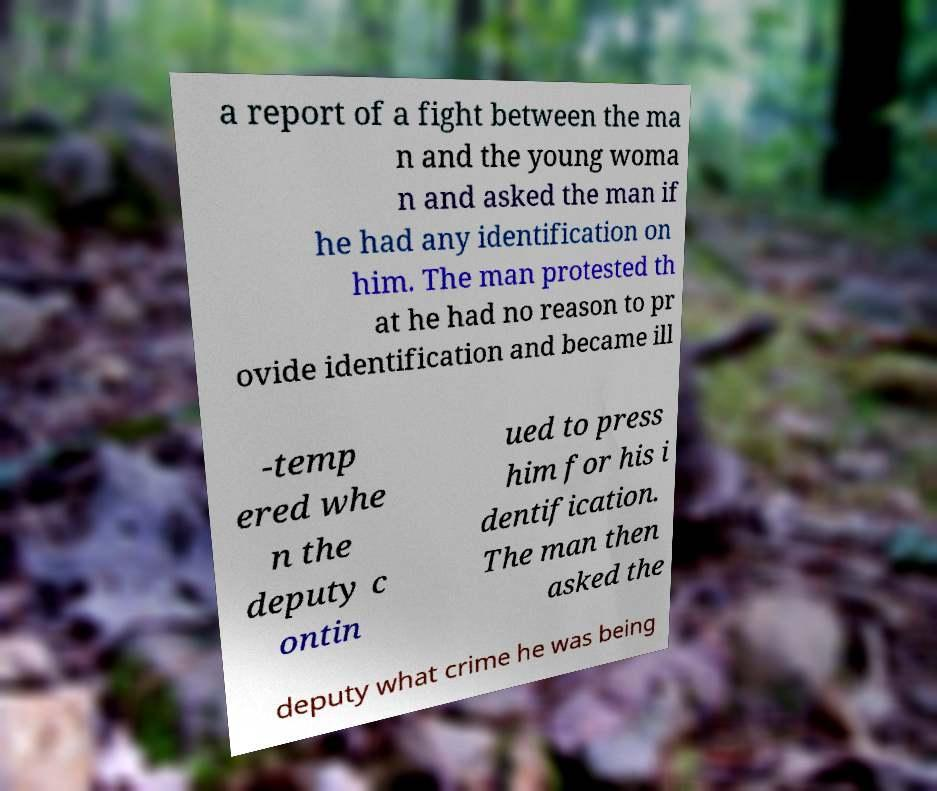Can you accurately transcribe the text from the provided image for me? a report of a fight between the ma n and the young woma n and asked the man if he had any identification on him. The man protested th at he had no reason to pr ovide identification and became ill -temp ered whe n the deputy c ontin ued to press him for his i dentification. The man then asked the deputy what crime he was being 